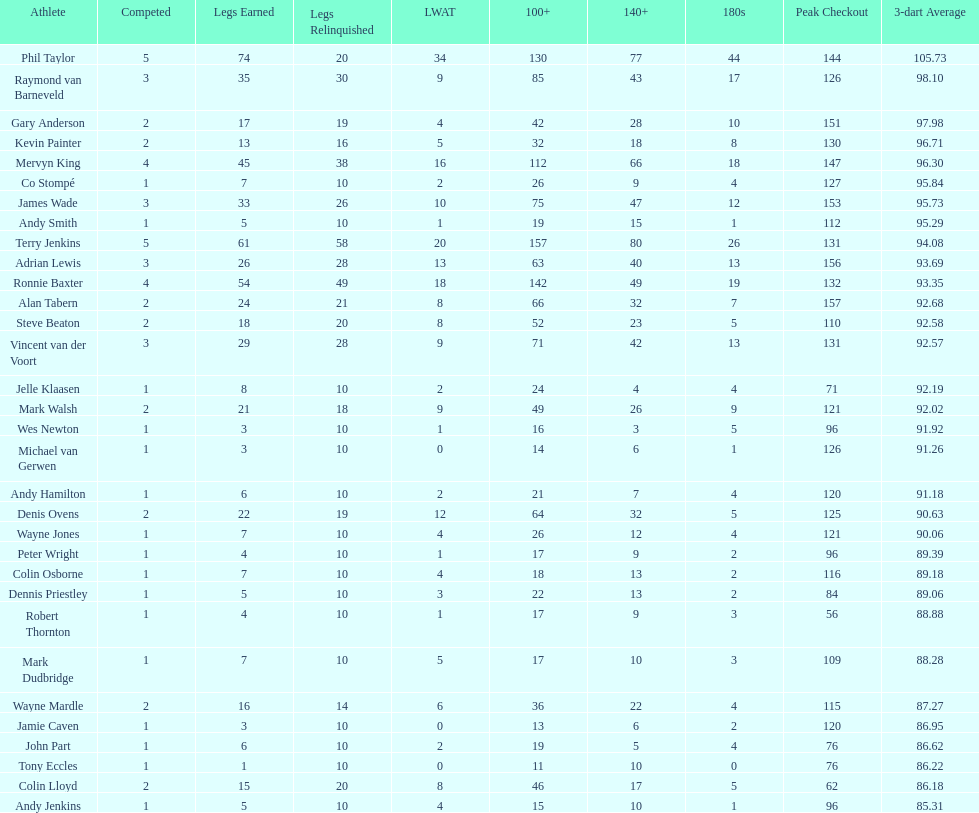List each of the players with a high checkout of 131. Terry Jenkins, Vincent van der Voort. Would you be able to parse every entry in this table? {'header': ['Athlete', 'Competed', 'Legs Earned', 'Legs Relinquished', 'LWAT', '100+', '140+', '180s', 'Peak Checkout', '3-dart Average'], 'rows': [['Phil Taylor', '5', '74', '20', '34', '130', '77', '44', '144', '105.73'], ['Raymond van Barneveld', '3', '35', '30', '9', '85', '43', '17', '126', '98.10'], ['Gary Anderson', '2', '17', '19', '4', '42', '28', '10', '151', '97.98'], ['Kevin Painter', '2', '13', '16', '5', '32', '18', '8', '130', '96.71'], ['Mervyn King', '4', '45', '38', '16', '112', '66', '18', '147', '96.30'], ['Co Stompé', '1', '7', '10', '2', '26', '9', '4', '127', '95.84'], ['James Wade', '3', '33', '26', '10', '75', '47', '12', '153', '95.73'], ['Andy Smith', '1', '5', '10', '1', '19', '15', '1', '112', '95.29'], ['Terry Jenkins', '5', '61', '58', '20', '157', '80', '26', '131', '94.08'], ['Adrian Lewis', '3', '26', '28', '13', '63', '40', '13', '156', '93.69'], ['Ronnie Baxter', '4', '54', '49', '18', '142', '49', '19', '132', '93.35'], ['Alan Tabern', '2', '24', '21', '8', '66', '32', '7', '157', '92.68'], ['Steve Beaton', '2', '18', '20', '8', '52', '23', '5', '110', '92.58'], ['Vincent van der Voort', '3', '29', '28', '9', '71', '42', '13', '131', '92.57'], ['Jelle Klaasen', '1', '8', '10', '2', '24', '4', '4', '71', '92.19'], ['Mark Walsh', '2', '21', '18', '9', '49', '26', '9', '121', '92.02'], ['Wes Newton', '1', '3', '10', '1', '16', '3', '5', '96', '91.92'], ['Michael van Gerwen', '1', '3', '10', '0', '14', '6', '1', '126', '91.26'], ['Andy Hamilton', '1', '6', '10', '2', '21', '7', '4', '120', '91.18'], ['Denis Ovens', '2', '22', '19', '12', '64', '32', '5', '125', '90.63'], ['Wayne Jones', '1', '7', '10', '4', '26', '12', '4', '121', '90.06'], ['Peter Wright', '1', '4', '10', '1', '17', '9', '2', '96', '89.39'], ['Colin Osborne', '1', '7', '10', '4', '18', '13', '2', '116', '89.18'], ['Dennis Priestley', '1', '5', '10', '3', '22', '13', '2', '84', '89.06'], ['Robert Thornton', '1', '4', '10', '1', '17', '9', '3', '56', '88.88'], ['Mark Dudbridge', '1', '7', '10', '5', '17', '10', '3', '109', '88.28'], ['Wayne Mardle', '2', '16', '14', '6', '36', '22', '4', '115', '87.27'], ['Jamie Caven', '1', '3', '10', '0', '13', '6', '2', '120', '86.95'], ['John Part', '1', '6', '10', '2', '19', '5', '4', '76', '86.62'], ['Tony Eccles', '1', '1', '10', '0', '11', '10', '0', '76', '86.22'], ['Colin Lloyd', '2', '15', '20', '8', '46', '17', '5', '62', '86.18'], ['Andy Jenkins', '1', '5', '10', '4', '15', '10', '1', '96', '85.31']]} 